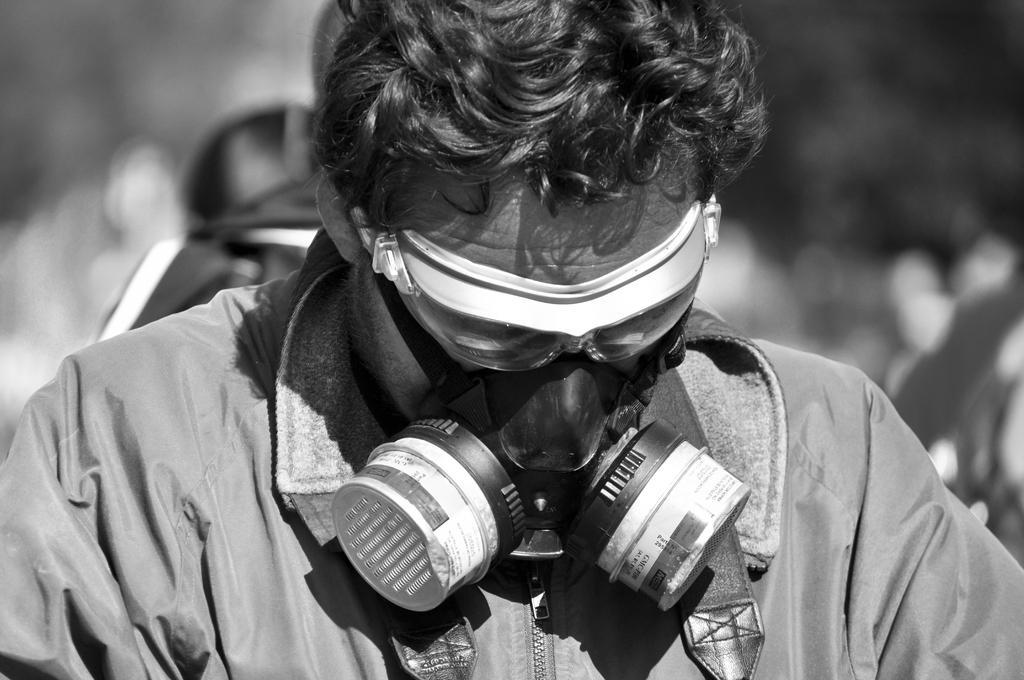Could you give a brief overview of what you see in this image? This is a black and white image where we can see a person wearing jacket and face mask is here. The background of the image is blurred. 